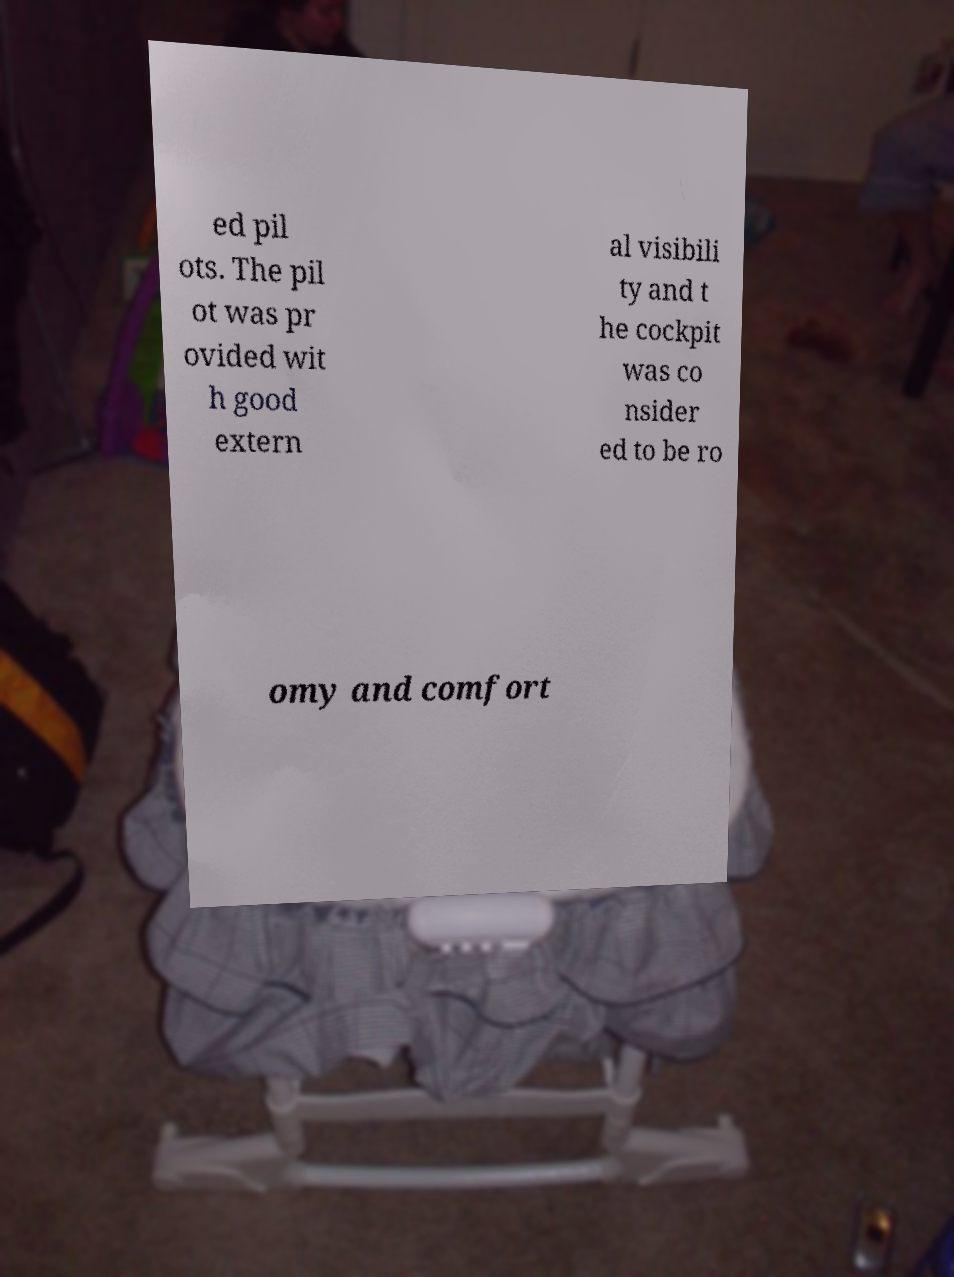Can you accurately transcribe the text from the provided image for me? ed pil ots. The pil ot was pr ovided wit h good extern al visibili ty and t he cockpit was co nsider ed to be ro omy and comfort 